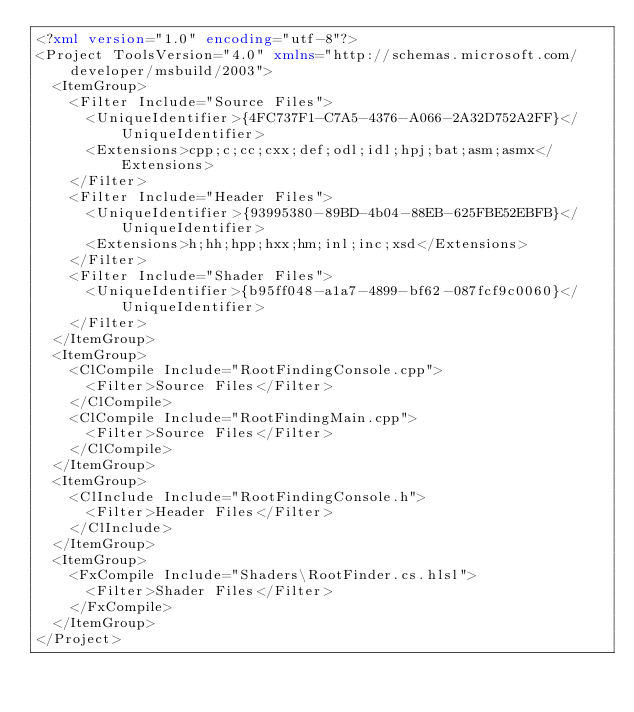<code> <loc_0><loc_0><loc_500><loc_500><_XML_><?xml version="1.0" encoding="utf-8"?>
<Project ToolsVersion="4.0" xmlns="http://schemas.microsoft.com/developer/msbuild/2003">
  <ItemGroup>
    <Filter Include="Source Files">
      <UniqueIdentifier>{4FC737F1-C7A5-4376-A066-2A32D752A2FF}</UniqueIdentifier>
      <Extensions>cpp;c;cc;cxx;def;odl;idl;hpj;bat;asm;asmx</Extensions>
    </Filter>
    <Filter Include="Header Files">
      <UniqueIdentifier>{93995380-89BD-4b04-88EB-625FBE52EBFB}</UniqueIdentifier>
      <Extensions>h;hh;hpp;hxx;hm;inl;inc;xsd</Extensions>
    </Filter>
    <Filter Include="Shader Files">
      <UniqueIdentifier>{b95ff048-a1a7-4899-bf62-087fcf9c0060}</UniqueIdentifier>
    </Filter>
  </ItemGroup>
  <ItemGroup>
    <ClCompile Include="RootFindingConsole.cpp">
      <Filter>Source Files</Filter>
    </ClCompile>
    <ClCompile Include="RootFindingMain.cpp">
      <Filter>Source Files</Filter>
    </ClCompile>
  </ItemGroup>
  <ItemGroup>
    <ClInclude Include="RootFindingConsole.h">
      <Filter>Header Files</Filter>
    </ClInclude>
  </ItemGroup>
  <ItemGroup>
    <FxCompile Include="Shaders\RootFinder.cs.hlsl">
      <Filter>Shader Files</Filter>
    </FxCompile>
  </ItemGroup>
</Project></code> 